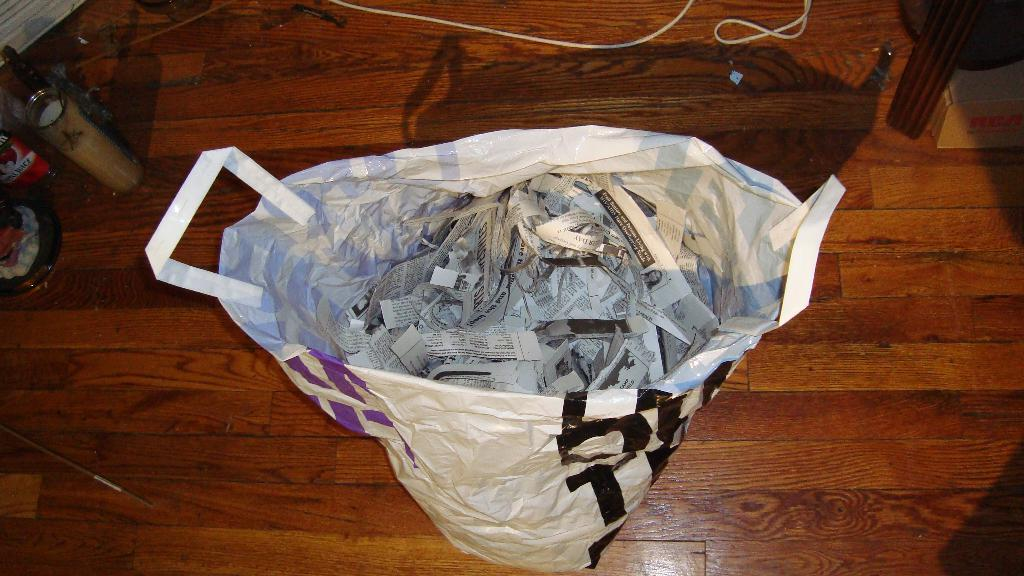What object is visible in the image that is made of plastic? There is a plastic bag in the image. What is inside the plastic bag? The plastic bag contains papers. What type of material is the wire made of? The wire at the top of the image is not specified, but it appears to be metallic. Can you see any clouds in the image? There are no clouds visible in the image. Is there a goat present in the image? There is no goat present in the image. 